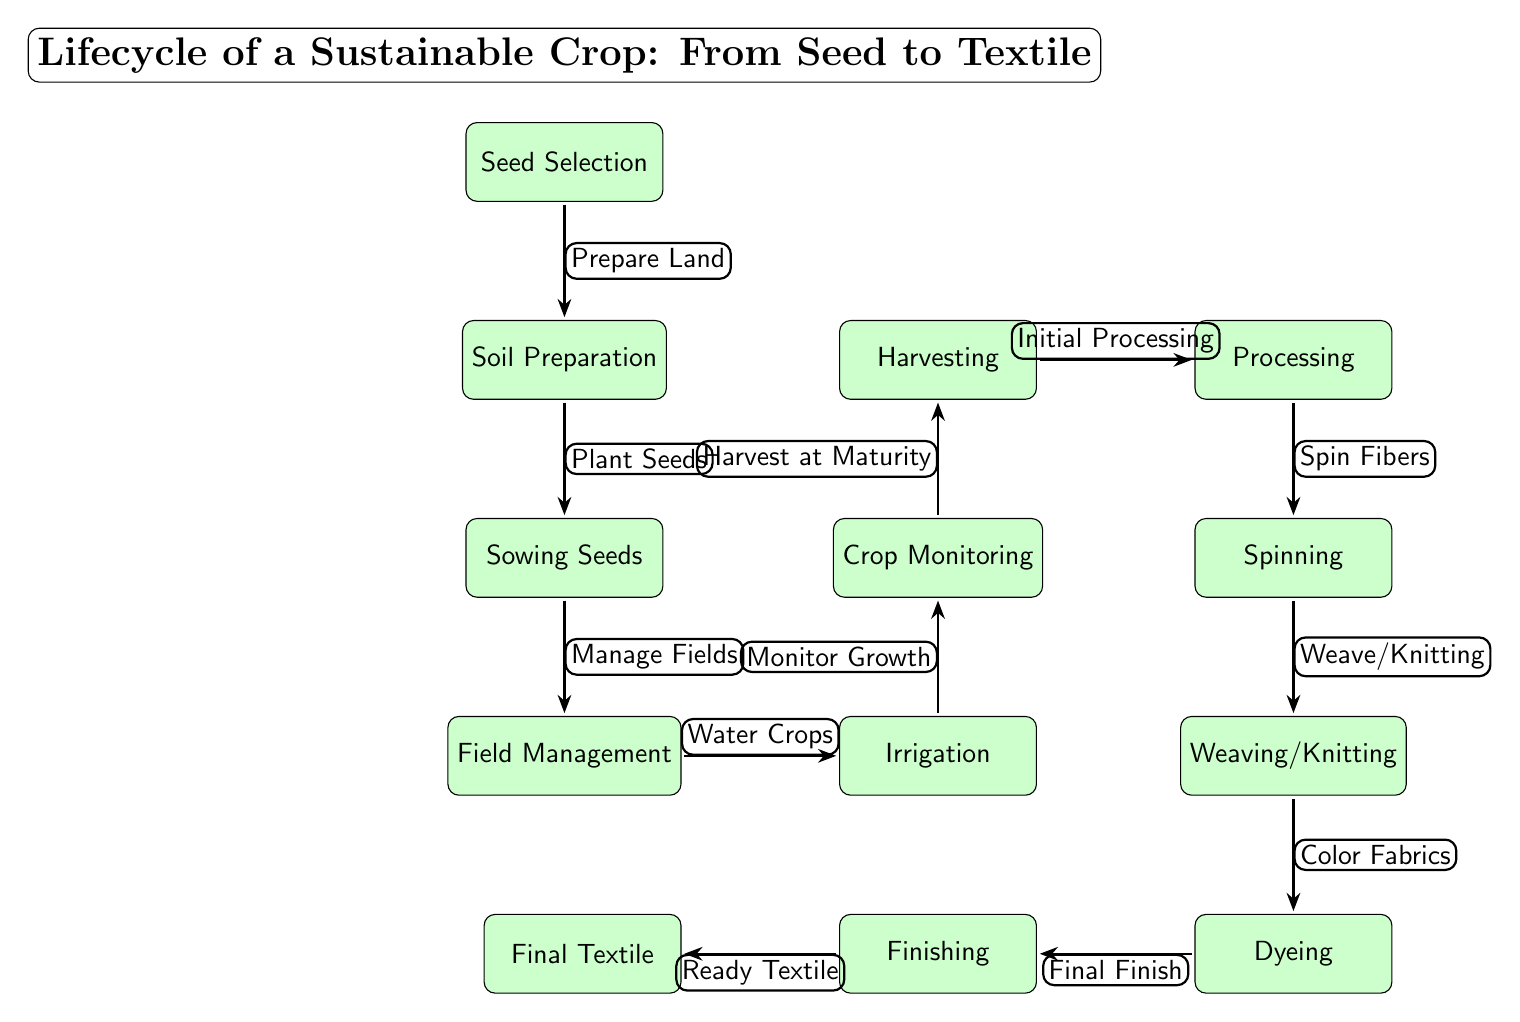What is the first step in the lifecycle? The first step in the lifecycle is indicated by the topmost node in the diagram, which is "Seed Selection." This node represents the initial phase of the crop lifecycle before any planting occurs.
Answer: Seed Selection How many processes are there in total? To find the total number of processes, count all the individual nodes labeled as processes in the diagram. Counting each node yields a total of 11 processes.
Answer: 11 What is done after harvesting? Moving from the "Harvesting" node, the next step in the sequence is "Processing," which signifies the transition from the crop stage to the textile production phase.
Answer: Processing Which process involves monitoring crops? The diagram shows "Crop Monitoring" as the specific process dedicated to monitoring the growth and health of the crops. This step follows the irrigation phase in the lifecycle sequence.
Answer: Crop Monitoring Which two processes are directly connected? The processes "Field Management" and "Irrigation" are linked directly by an arrow, indicating that "Irrigation" follows "Field Management" in the process sequence.
Answer: Field Management and Irrigation What is the final step of the lifecycle? The last node in the diagram is "Final Textile," which represents the completion of the crop lifecycle, transitioning into a finished textile product.
Answer: Final Textile What step occurs before dyeing? Before reaching the "Dyeing" process, one must first complete "Weaving/Knitting," as it is the immediate predecessor of dyeing within the diagram's flow.
Answer: Weaving/Knitting What stage requires spinning fibers? The "Spinning" process is required before the output of woven or knitted materials; it indicates where fibers are transformed into thread or yarn. This process is directly after "Processing."
Answer: Spinning Which processes include water-related tasks? The processes that involve water-related tasks are "Irrigation," where crops are watered, and "Field Management," where the general care of the crops, including water management, occurs.
Answer: Irrigation and Field Management 